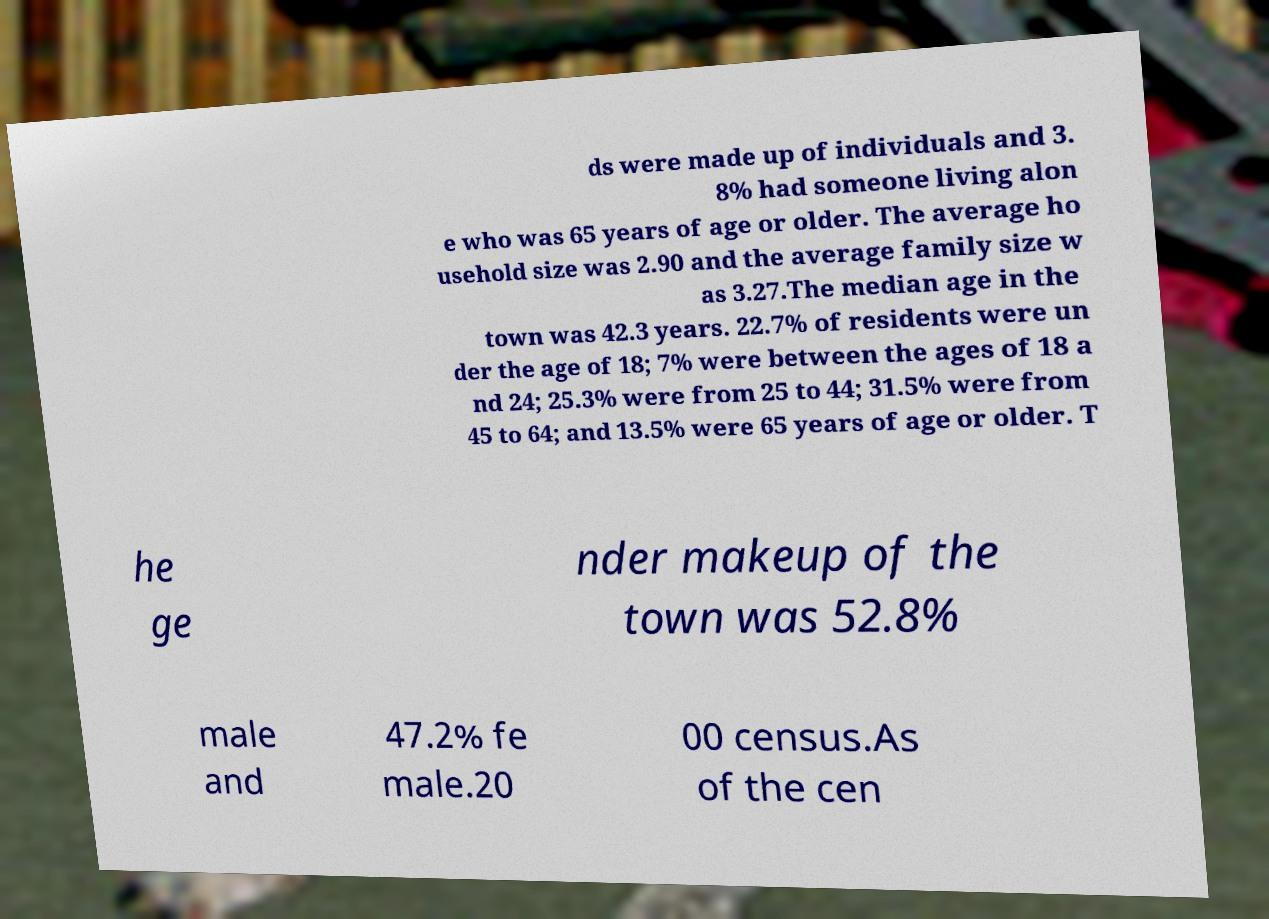What messages or text are displayed in this image? I need them in a readable, typed format. ds were made up of individuals and 3. 8% had someone living alon e who was 65 years of age or older. The average ho usehold size was 2.90 and the average family size w as 3.27.The median age in the town was 42.3 years. 22.7% of residents were un der the age of 18; 7% were between the ages of 18 a nd 24; 25.3% were from 25 to 44; 31.5% were from 45 to 64; and 13.5% were 65 years of age or older. T he ge nder makeup of the town was 52.8% male and 47.2% fe male.20 00 census.As of the cen 